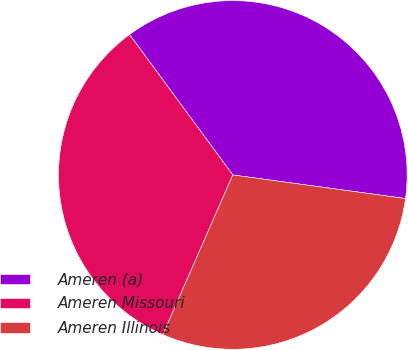Convert chart to OTSL. <chart><loc_0><loc_0><loc_500><loc_500><pie_chart><fcel>Ameren (a)<fcel>Ameren Missouri<fcel>Ameren Illinois<nl><fcel>37.25%<fcel>33.33%<fcel>29.41%<nl></chart> 